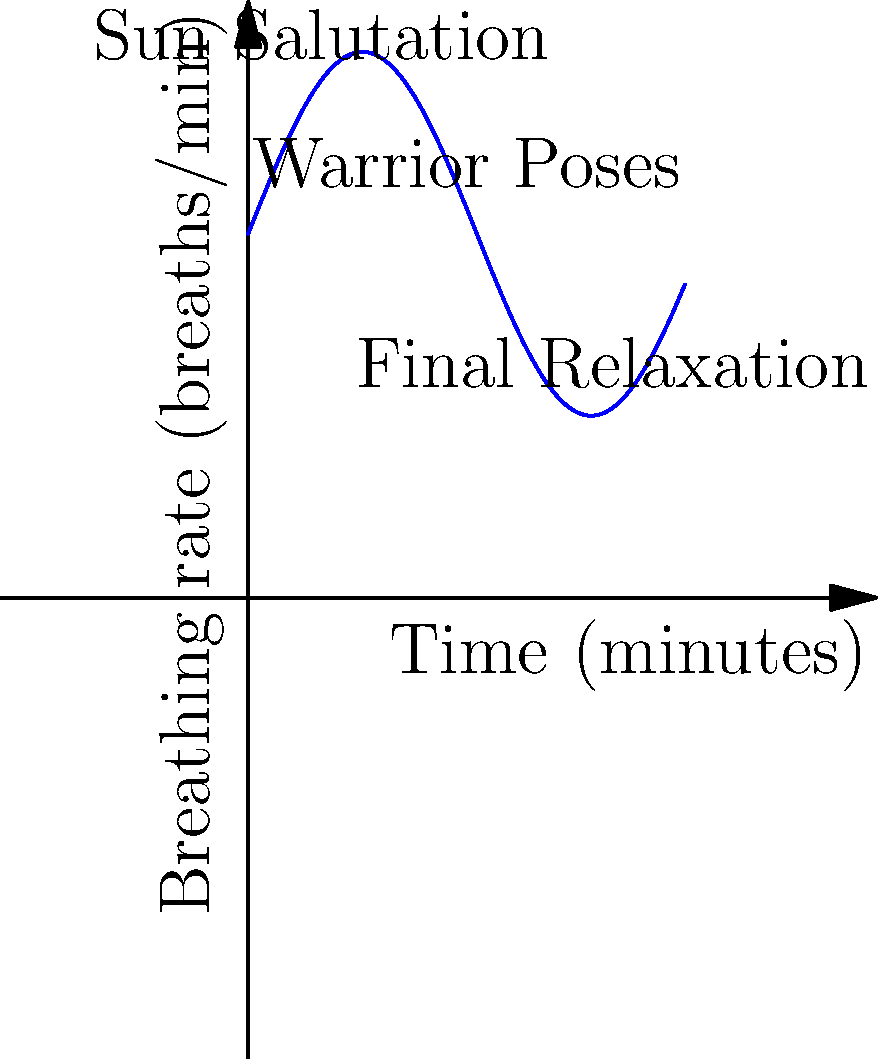The graph shows the breathing rate during a 12-minute yoga sequence. The breathing rate $R(t)$ in breaths per minute at time $t$ in minutes is modeled by the function:

$R(t) = 10 + 5\sin(\frac{t}{2})$

Calculate the total number of breaths taken during this 12-minute sequence. To find the total number of breaths, we need to integrate the breathing rate function over the 12-minute interval:

1) Set up the integral:
   $\text{Total breaths} = \int_0^{12} R(t) dt = \int_0^{12} (10 + 5\sin(\frac{t}{2})) dt$

2) Split the integral:
   $\int_0^{12} 10 dt + \int_0^{12} 5\sin(\frac{t}{2}) dt$

3) Evaluate the first part:
   $10t \big|_0^{12} = 120$

4) For the second part, use substitution:
   Let $u = \frac{t}{2}$, then $du = \frac{1}{2}dt$, and $dt = 2du$
   New limits: when $t=0$, $u=0$; when $t=12$, $u=6$

   $5\int_0^6 \sin(u) \cdot 2du = 10\int_0^6 \sin(u) du$

5) Evaluate:
   $10[-\cos(u)]_0^6 = 10[-\cos(6) + \cos(0)] = 10[1 - \cos(6)]$

6) Add the results:
   Total breaths $= 120 + 10[1 - \cos(6)] \approx 124.92$
Answer: Approximately 125 breaths 